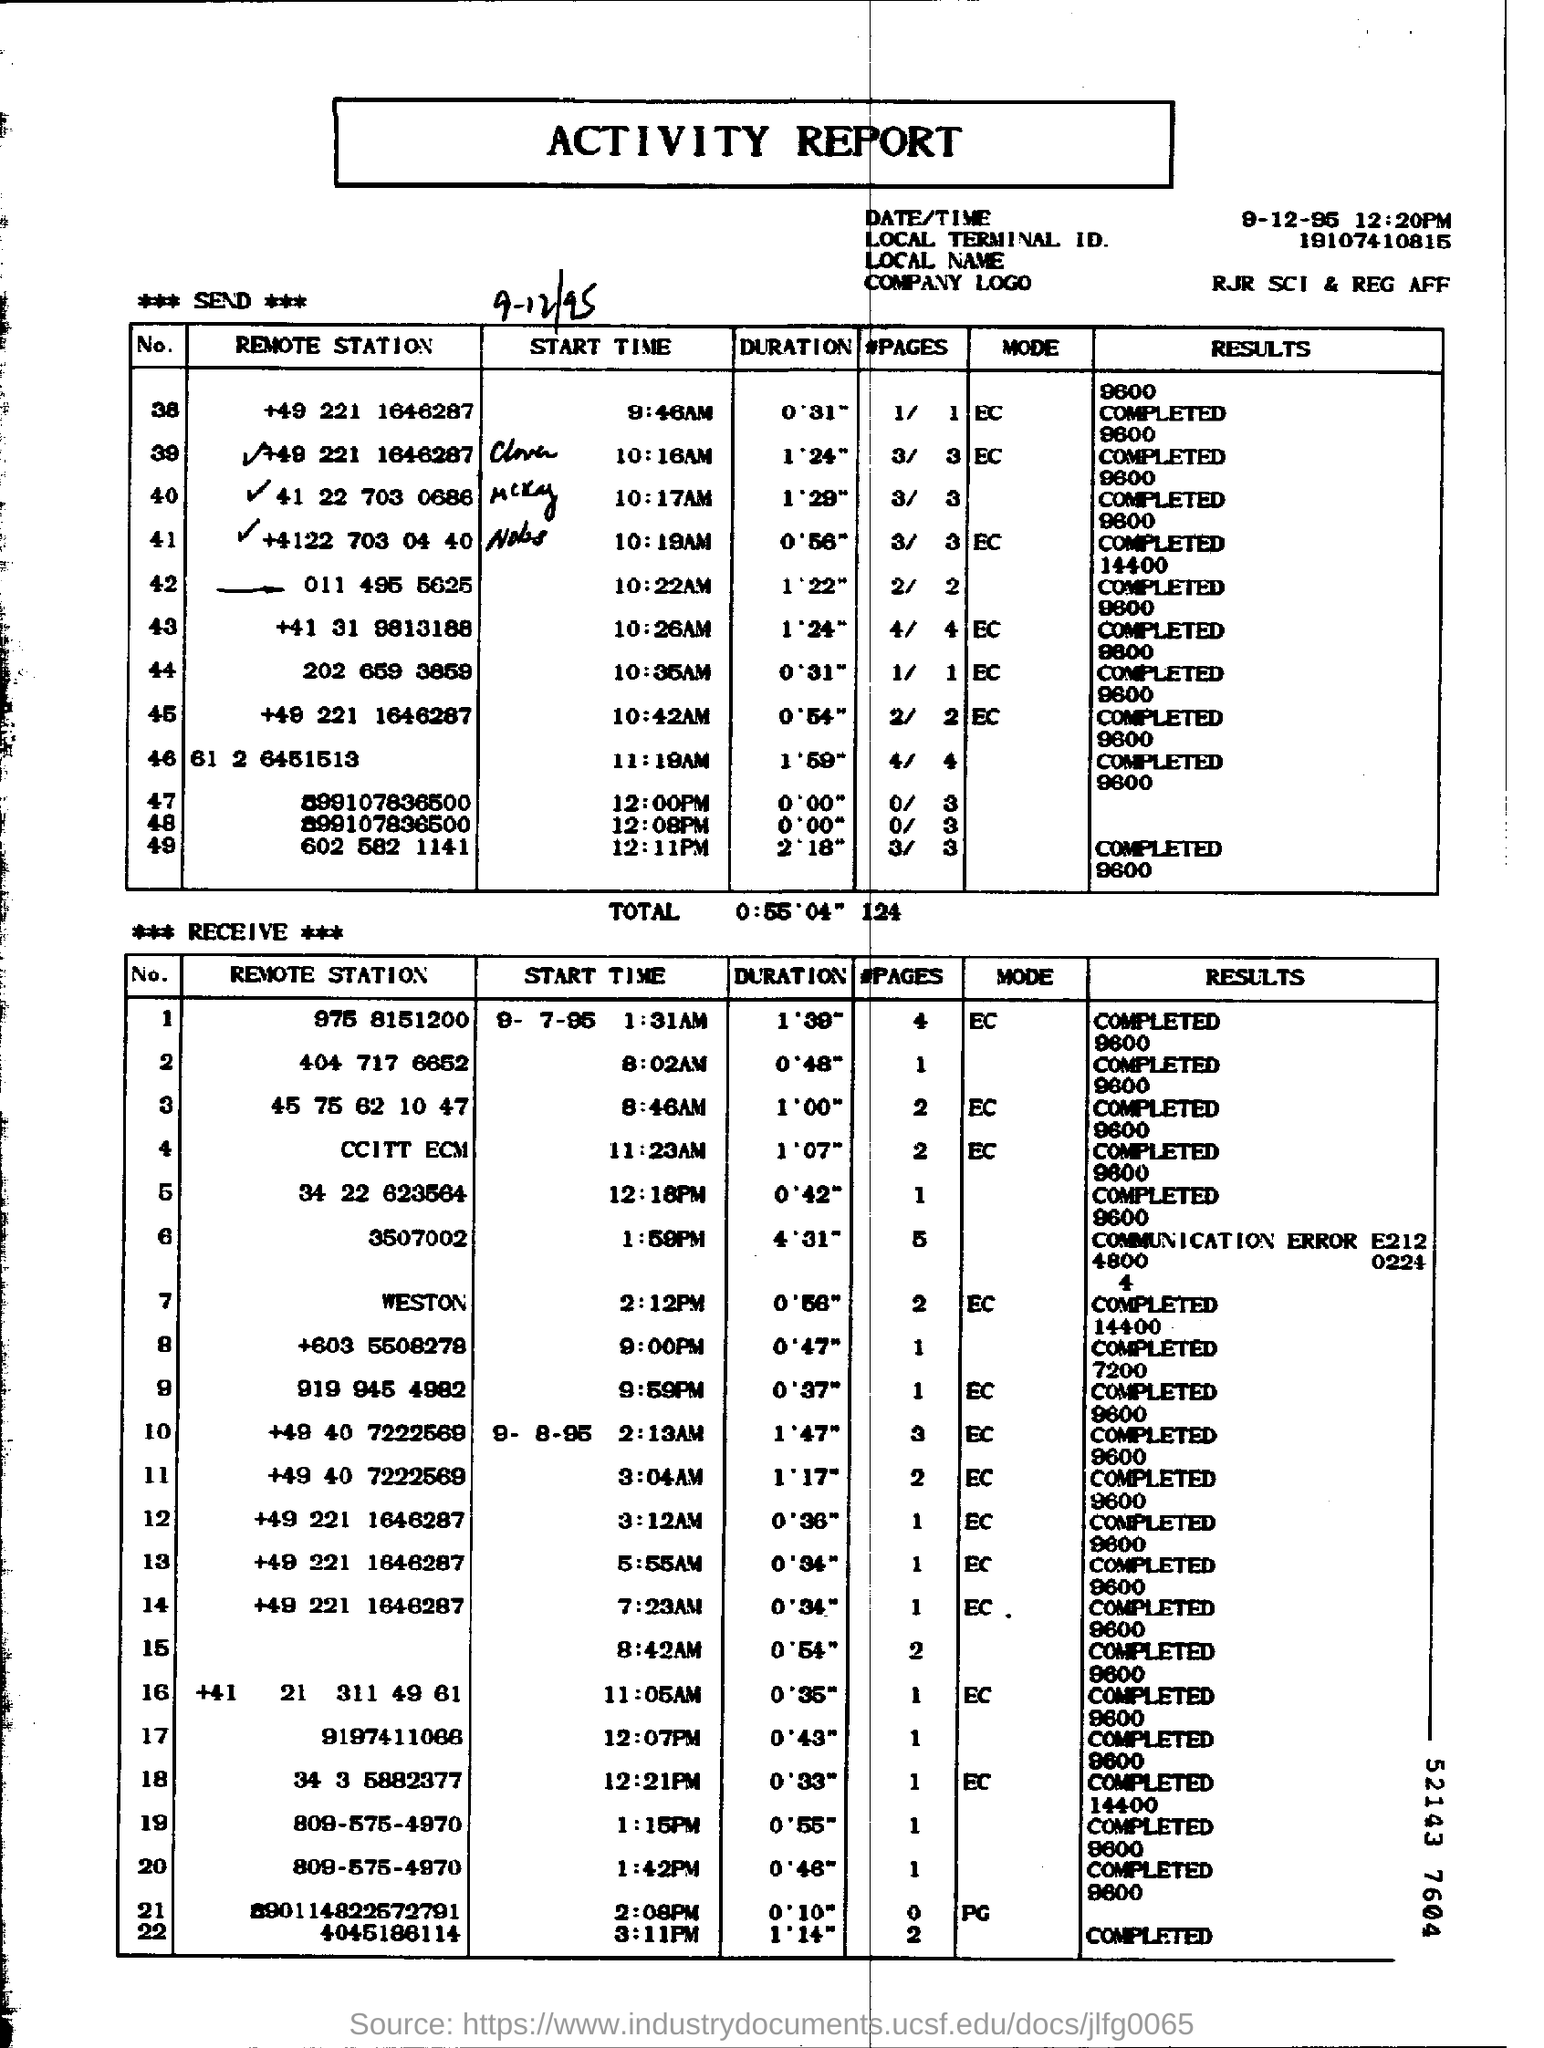Draw attention to some important aspects in this diagram. This is an activity report. The local terminal ID is 19107410815... 